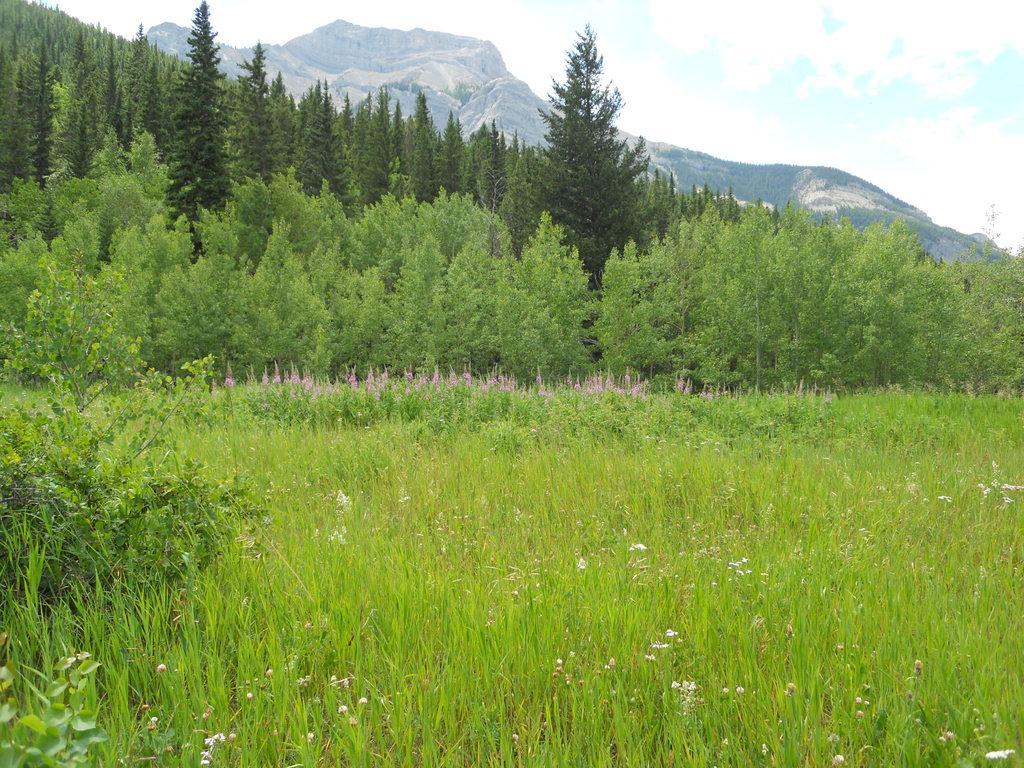Describe this image in one or two sentences. In the picture we can see grass plants and just a far from it, we can see some plants, trees and hill and behind it, we can see a mountain and in the background we can see a sky with clouds. 